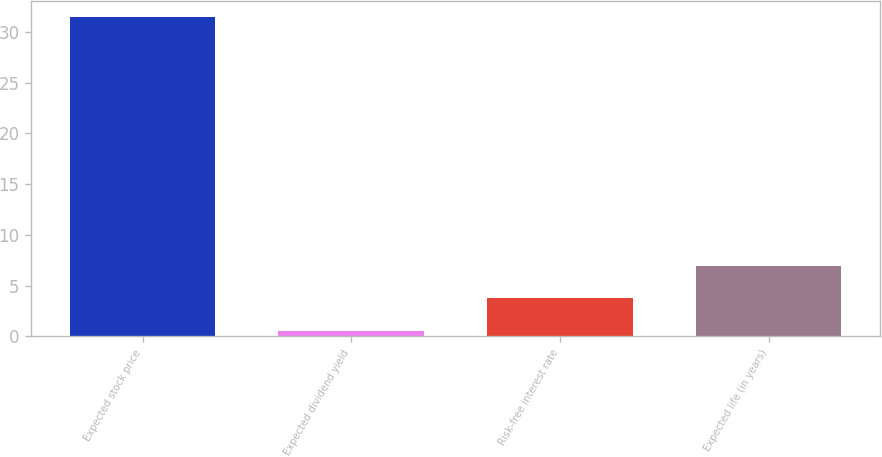Convert chart to OTSL. <chart><loc_0><loc_0><loc_500><loc_500><bar_chart><fcel>Expected stock price<fcel>Expected dividend yield<fcel>Risk-free interest rate<fcel>Expected life (in years)<nl><fcel>31.5<fcel>0.52<fcel>3.8<fcel>6.9<nl></chart> 